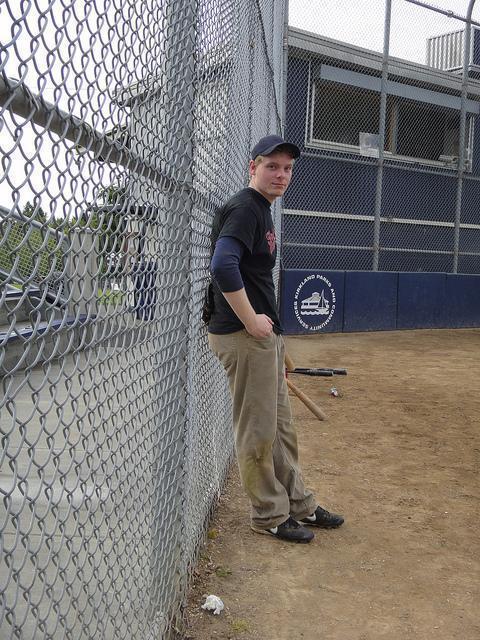What is he doing?
Indicate the correct response by choosing from the four available options to answer the question.
Options: Posing, drinking, eating, playing baseball. Posing. 